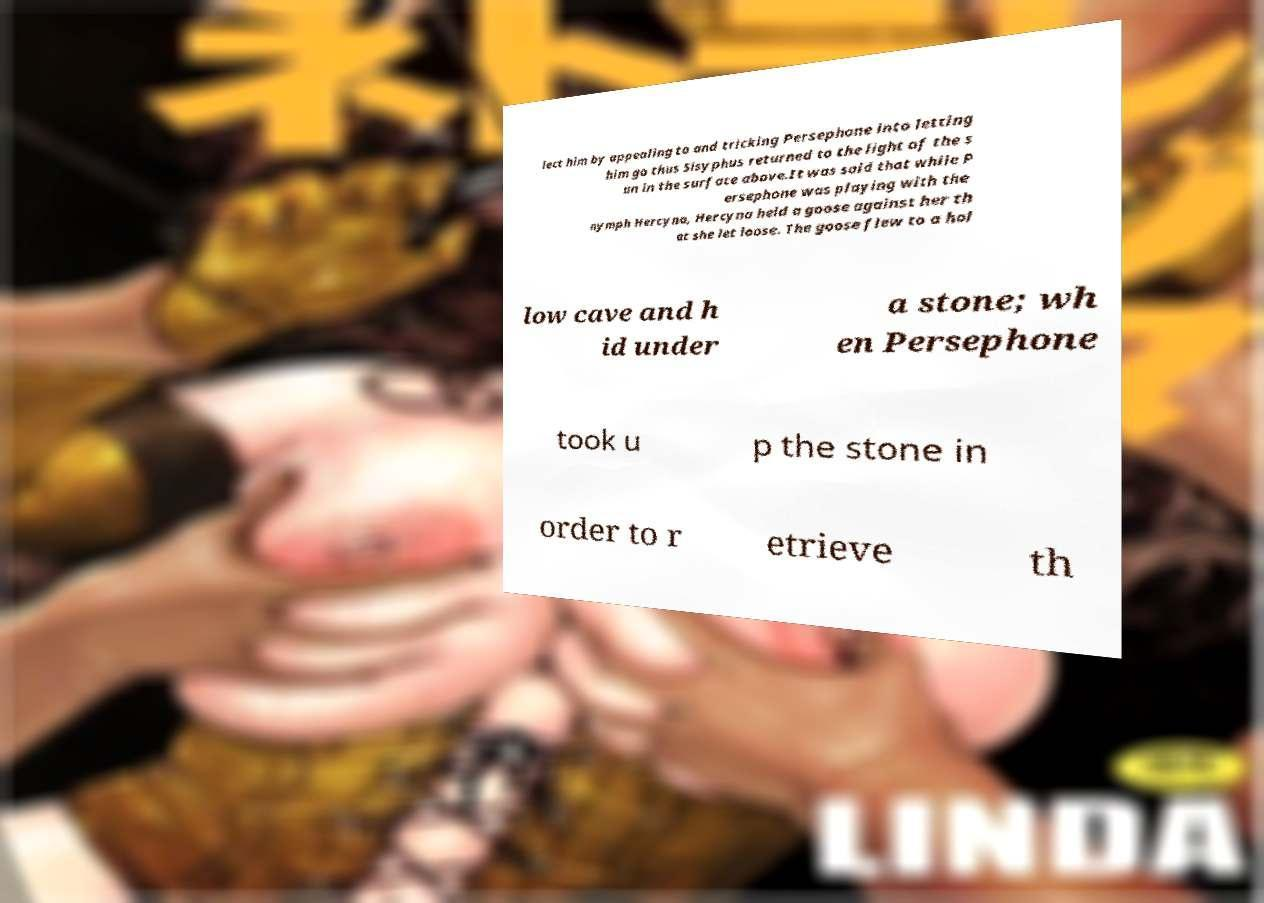I need the written content from this picture converted into text. Can you do that? lect him by appealing to and tricking Persephone into letting him go thus Sisyphus returned to the light of the s un in the surface above.It was said that while P ersephone was playing with the nymph Hercyna, Hercyna held a goose against her th at she let loose. The goose flew to a hol low cave and h id under a stone; wh en Persephone took u p the stone in order to r etrieve th 